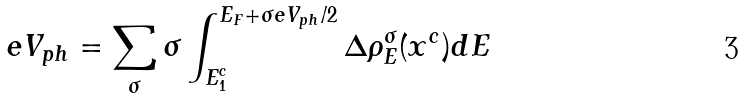Convert formula to latex. <formula><loc_0><loc_0><loc_500><loc_500>e V _ { p h } = \sum _ { \sigma } \sigma \int _ { E _ { 1 } ^ { c } } ^ { E _ { F } + \sigma e V _ { p h } / 2 } \Delta \rho ^ { \sigma } _ { E } ( x ^ { c } ) d E</formula> 